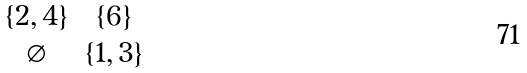Convert formula to latex. <formula><loc_0><loc_0><loc_500><loc_500>\begin{matrix} \{ 2 , 4 \} & \{ 6 \} \\ \varnothing & \{ 1 , 3 \} \end{matrix}</formula> 